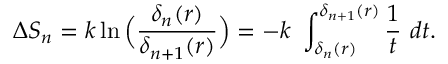Convert formula to latex. <formula><loc_0><loc_0><loc_500><loc_500>\Delta S _ { n } = k \ln \left ( { \frac { \delta _ { n } ( r ) } { \delta _ { n + 1 } ( r ) } } \right ) = - k \ \int _ { \delta _ { n } ( r ) } ^ { \delta _ { n + 1 } ( r ) } { \frac { 1 } { t } } \ d t .</formula> 